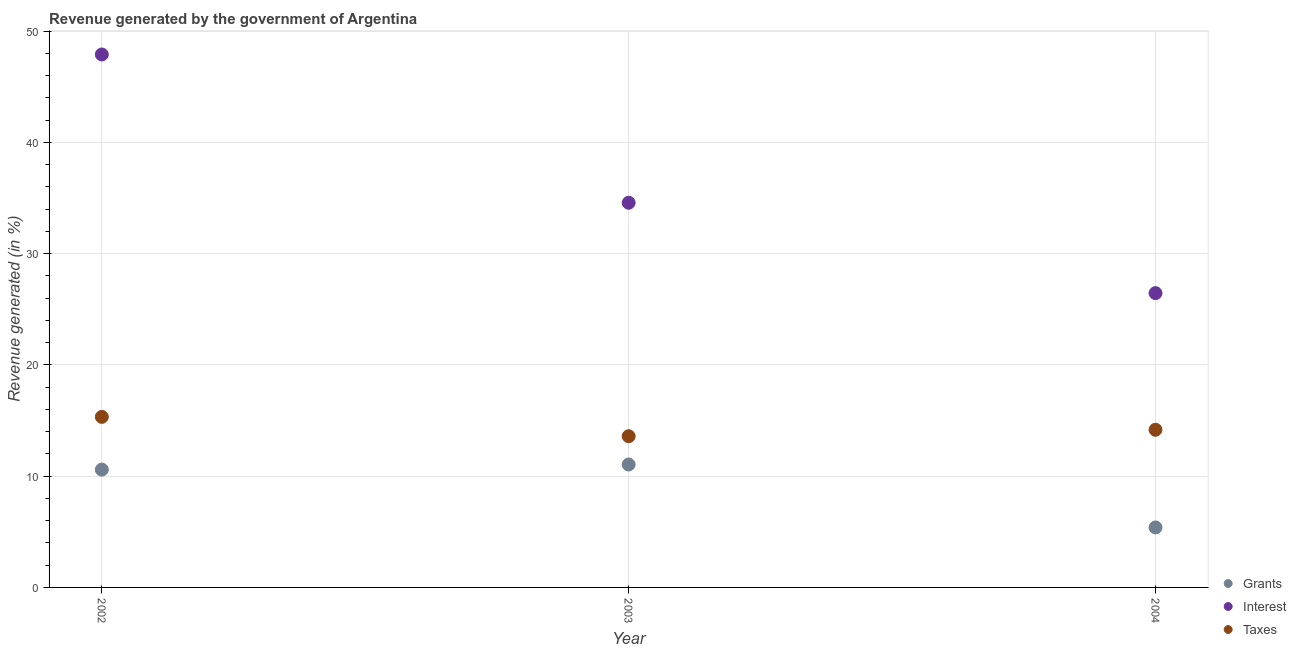How many different coloured dotlines are there?
Offer a very short reply. 3. What is the percentage of revenue generated by interest in 2003?
Keep it short and to the point. 34.58. Across all years, what is the maximum percentage of revenue generated by interest?
Give a very brief answer. 47.91. Across all years, what is the minimum percentage of revenue generated by taxes?
Make the answer very short. 13.59. In which year was the percentage of revenue generated by grants maximum?
Your answer should be very brief. 2003. In which year was the percentage of revenue generated by interest minimum?
Your response must be concise. 2004. What is the total percentage of revenue generated by grants in the graph?
Provide a short and direct response. 27.04. What is the difference between the percentage of revenue generated by grants in 2002 and that in 2004?
Keep it short and to the point. 5.2. What is the difference between the percentage of revenue generated by taxes in 2003 and the percentage of revenue generated by interest in 2004?
Offer a terse response. -12.86. What is the average percentage of revenue generated by interest per year?
Keep it short and to the point. 36.32. In the year 2003, what is the difference between the percentage of revenue generated by interest and percentage of revenue generated by taxes?
Ensure brevity in your answer.  20.99. In how many years, is the percentage of revenue generated by taxes greater than 28 %?
Provide a short and direct response. 0. What is the ratio of the percentage of revenue generated by grants in 2002 to that in 2003?
Offer a very short reply. 0.96. Is the percentage of revenue generated by taxes in 2003 less than that in 2004?
Your answer should be very brief. Yes. Is the difference between the percentage of revenue generated by grants in 2002 and 2004 greater than the difference between the percentage of revenue generated by taxes in 2002 and 2004?
Ensure brevity in your answer.  Yes. What is the difference between the highest and the second highest percentage of revenue generated by taxes?
Your response must be concise. 1.16. What is the difference between the highest and the lowest percentage of revenue generated by grants?
Offer a very short reply. 5.66. In how many years, is the percentage of revenue generated by interest greater than the average percentage of revenue generated by interest taken over all years?
Offer a very short reply. 1. Is the sum of the percentage of revenue generated by interest in 2002 and 2004 greater than the maximum percentage of revenue generated by taxes across all years?
Ensure brevity in your answer.  Yes. Does the percentage of revenue generated by interest monotonically increase over the years?
Your answer should be very brief. No. Is the percentage of revenue generated by grants strictly less than the percentage of revenue generated by taxes over the years?
Your answer should be very brief. Yes. How many dotlines are there?
Your response must be concise. 3. How many years are there in the graph?
Your answer should be very brief. 3. What is the difference between two consecutive major ticks on the Y-axis?
Your answer should be compact. 10. Are the values on the major ticks of Y-axis written in scientific E-notation?
Ensure brevity in your answer.  No. Does the graph contain grids?
Offer a very short reply. Yes. How many legend labels are there?
Your answer should be compact. 3. How are the legend labels stacked?
Provide a short and direct response. Vertical. What is the title of the graph?
Keep it short and to the point. Revenue generated by the government of Argentina. What is the label or title of the Y-axis?
Provide a succinct answer. Revenue generated (in %). What is the Revenue generated (in %) of Grants in 2002?
Your answer should be compact. 10.59. What is the Revenue generated (in %) of Interest in 2002?
Your answer should be very brief. 47.91. What is the Revenue generated (in %) in Taxes in 2002?
Your answer should be compact. 15.33. What is the Revenue generated (in %) in Grants in 2003?
Offer a very short reply. 11.05. What is the Revenue generated (in %) of Interest in 2003?
Make the answer very short. 34.58. What is the Revenue generated (in %) in Taxes in 2003?
Your answer should be compact. 13.59. What is the Revenue generated (in %) of Grants in 2004?
Your answer should be very brief. 5.39. What is the Revenue generated (in %) in Interest in 2004?
Keep it short and to the point. 26.46. What is the Revenue generated (in %) of Taxes in 2004?
Ensure brevity in your answer.  14.17. Across all years, what is the maximum Revenue generated (in %) of Grants?
Your response must be concise. 11.05. Across all years, what is the maximum Revenue generated (in %) in Interest?
Give a very brief answer. 47.91. Across all years, what is the maximum Revenue generated (in %) in Taxes?
Your answer should be very brief. 15.33. Across all years, what is the minimum Revenue generated (in %) of Grants?
Keep it short and to the point. 5.39. Across all years, what is the minimum Revenue generated (in %) of Interest?
Ensure brevity in your answer.  26.46. Across all years, what is the minimum Revenue generated (in %) in Taxes?
Your response must be concise. 13.59. What is the total Revenue generated (in %) of Grants in the graph?
Offer a very short reply. 27.04. What is the total Revenue generated (in %) in Interest in the graph?
Ensure brevity in your answer.  108.95. What is the total Revenue generated (in %) of Taxes in the graph?
Offer a very short reply. 43.1. What is the difference between the Revenue generated (in %) of Grants in 2002 and that in 2003?
Your answer should be very brief. -0.46. What is the difference between the Revenue generated (in %) in Interest in 2002 and that in 2003?
Give a very brief answer. 13.33. What is the difference between the Revenue generated (in %) in Taxes in 2002 and that in 2003?
Your answer should be very brief. 1.74. What is the difference between the Revenue generated (in %) of Grants in 2002 and that in 2004?
Offer a terse response. 5.2. What is the difference between the Revenue generated (in %) in Interest in 2002 and that in 2004?
Ensure brevity in your answer.  21.45. What is the difference between the Revenue generated (in %) in Taxes in 2002 and that in 2004?
Your answer should be compact. 1.16. What is the difference between the Revenue generated (in %) in Grants in 2003 and that in 2004?
Provide a succinct answer. 5.66. What is the difference between the Revenue generated (in %) of Interest in 2003 and that in 2004?
Make the answer very short. 8.12. What is the difference between the Revenue generated (in %) in Taxes in 2003 and that in 2004?
Offer a terse response. -0.58. What is the difference between the Revenue generated (in %) of Grants in 2002 and the Revenue generated (in %) of Interest in 2003?
Make the answer very short. -23.99. What is the difference between the Revenue generated (in %) of Grants in 2002 and the Revenue generated (in %) of Taxes in 2003?
Provide a short and direct response. -3. What is the difference between the Revenue generated (in %) in Interest in 2002 and the Revenue generated (in %) in Taxes in 2003?
Keep it short and to the point. 34.32. What is the difference between the Revenue generated (in %) of Grants in 2002 and the Revenue generated (in %) of Interest in 2004?
Give a very brief answer. -15.87. What is the difference between the Revenue generated (in %) in Grants in 2002 and the Revenue generated (in %) in Taxes in 2004?
Give a very brief answer. -3.58. What is the difference between the Revenue generated (in %) of Interest in 2002 and the Revenue generated (in %) of Taxes in 2004?
Your answer should be compact. 33.74. What is the difference between the Revenue generated (in %) in Grants in 2003 and the Revenue generated (in %) in Interest in 2004?
Offer a terse response. -15.41. What is the difference between the Revenue generated (in %) of Grants in 2003 and the Revenue generated (in %) of Taxes in 2004?
Offer a terse response. -3.12. What is the difference between the Revenue generated (in %) in Interest in 2003 and the Revenue generated (in %) in Taxes in 2004?
Provide a succinct answer. 20.41. What is the average Revenue generated (in %) in Grants per year?
Offer a very short reply. 9.01. What is the average Revenue generated (in %) of Interest per year?
Your answer should be very brief. 36.32. What is the average Revenue generated (in %) in Taxes per year?
Your answer should be compact. 14.37. In the year 2002, what is the difference between the Revenue generated (in %) in Grants and Revenue generated (in %) in Interest?
Offer a very short reply. -37.32. In the year 2002, what is the difference between the Revenue generated (in %) in Grants and Revenue generated (in %) in Taxes?
Offer a very short reply. -4.74. In the year 2002, what is the difference between the Revenue generated (in %) of Interest and Revenue generated (in %) of Taxes?
Your answer should be very brief. 32.58. In the year 2003, what is the difference between the Revenue generated (in %) of Grants and Revenue generated (in %) of Interest?
Ensure brevity in your answer.  -23.53. In the year 2003, what is the difference between the Revenue generated (in %) of Grants and Revenue generated (in %) of Taxes?
Provide a short and direct response. -2.54. In the year 2003, what is the difference between the Revenue generated (in %) in Interest and Revenue generated (in %) in Taxes?
Offer a very short reply. 20.99. In the year 2004, what is the difference between the Revenue generated (in %) in Grants and Revenue generated (in %) in Interest?
Provide a short and direct response. -21.06. In the year 2004, what is the difference between the Revenue generated (in %) in Grants and Revenue generated (in %) in Taxes?
Your response must be concise. -8.78. In the year 2004, what is the difference between the Revenue generated (in %) of Interest and Revenue generated (in %) of Taxes?
Your answer should be compact. 12.28. What is the ratio of the Revenue generated (in %) of Grants in 2002 to that in 2003?
Your answer should be very brief. 0.96. What is the ratio of the Revenue generated (in %) of Interest in 2002 to that in 2003?
Ensure brevity in your answer.  1.39. What is the ratio of the Revenue generated (in %) of Taxes in 2002 to that in 2003?
Give a very brief answer. 1.13. What is the ratio of the Revenue generated (in %) of Grants in 2002 to that in 2004?
Make the answer very short. 1.96. What is the ratio of the Revenue generated (in %) of Interest in 2002 to that in 2004?
Offer a terse response. 1.81. What is the ratio of the Revenue generated (in %) of Taxes in 2002 to that in 2004?
Your answer should be very brief. 1.08. What is the ratio of the Revenue generated (in %) in Grants in 2003 to that in 2004?
Provide a short and direct response. 2.05. What is the ratio of the Revenue generated (in %) in Interest in 2003 to that in 2004?
Keep it short and to the point. 1.31. What is the ratio of the Revenue generated (in %) in Taxes in 2003 to that in 2004?
Provide a short and direct response. 0.96. What is the difference between the highest and the second highest Revenue generated (in %) of Grants?
Provide a succinct answer. 0.46. What is the difference between the highest and the second highest Revenue generated (in %) of Interest?
Give a very brief answer. 13.33. What is the difference between the highest and the second highest Revenue generated (in %) in Taxes?
Provide a short and direct response. 1.16. What is the difference between the highest and the lowest Revenue generated (in %) in Grants?
Provide a succinct answer. 5.66. What is the difference between the highest and the lowest Revenue generated (in %) of Interest?
Make the answer very short. 21.45. What is the difference between the highest and the lowest Revenue generated (in %) in Taxes?
Your answer should be very brief. 1.74. 